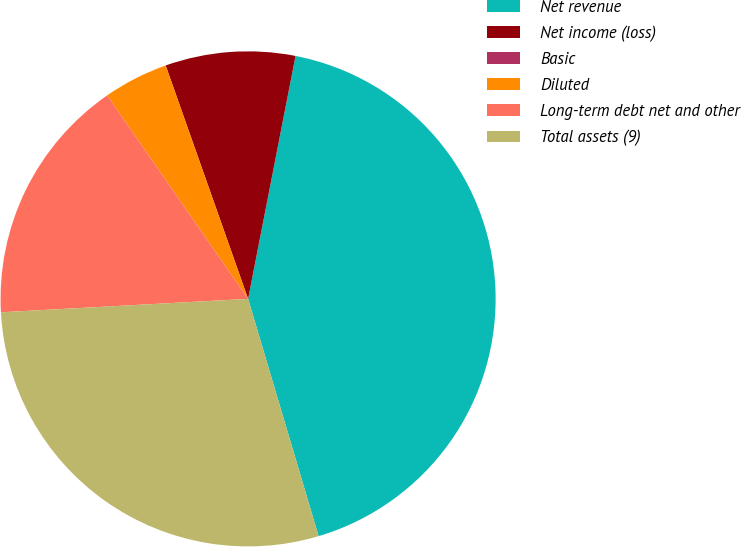Convert chart. <chart><loc_0><loc_0><loc_500><loc_500><pie_chart><fcel>Net revenue<fcel>Net income (loss)<fcel>Basic<fcel>Diluted<fcel>Long-term debt net and other<fcel>Total assets (9)<nl><fcel>42.33%<fcel>8.47%<fcel>0.0%<fcel>4.24%<fcel>16.22%<fcel>28.73%<nl></chart> 